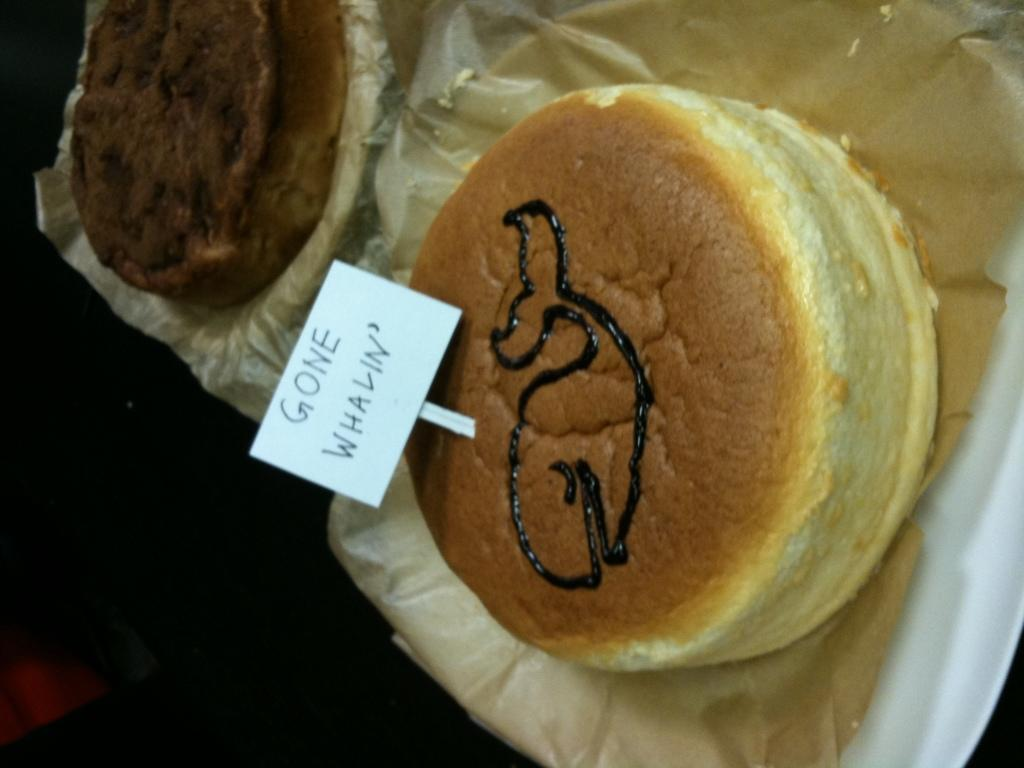What types of items can be seen in the image? There are food items in the image. Can you describe the text in the image? There is a text on a white object in the image. Are there any clams visible in the image? There is no mention of clams in the provided facts, and therefore we cannot determine if any are present in the image. What type of dinosaurs can be seen interacting with the food items in the image? There is no mention of dinosaurs in the provided facts, and therefore we cannot determine if any are present in the image. 